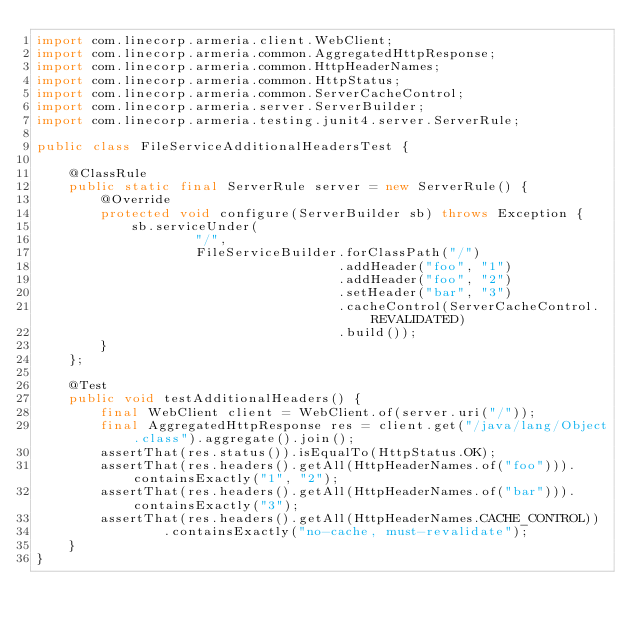<code> <loc_0><loc_0><loc_500><loc_500><_Java_>import com.linecorp.armeria.client.WebClient;
import com.linecorp.armeria.common.AggregatedHttpResponse;
import com.linecorp.armeria.common.HttpHeaderNames;
import com.linecorp.armeria.common.HttpStatus;
import com.linecorp.armeria.common.ServerCacheControl;
import com.linecorp.armeria.server.ServerBuilder;
import com.linecorp.armeria.testing.junit4.server.ServerRule;

public class FileServiceAdditionalHeadersTest {

    @ClassRule
    public static final ServerRule server = new ServerRule() {
        @Override
        protected void configure(ServerBuilder sb) throws Exception {
            sb.serviceUnder(
                    "/",
                    FileServiceBuilder.forClassPath("/")
                                      .addHeader("foo", "1")
                                      .addHeader("foo", "2")
                                      .setHeader("bar", "3")
                                      .cacheControl(ServerCacheControl.REVALIDATED)
                                      .build());
        }
    };

    @Test
    public void testAdditionalHeaders() {
        final WebClient client = WebClient.of(server.uri("/"));
        final AggregatedHttpResponse res = client.get("/java/lang/Object.class").aggregate().join();
        assertThat(res.status()).isEqualTo(HttpStatus.OK);
        assertThat(res.headers().getAll(HttpHeaderNames.of("foo"))).containsExactly("1", "2");
        assertThat(res.headers().getAll(HttpHeaderNames.of("bar"))).containsExactly("3");
        assertThat(res.headers().getAll(HttpHeaderNames.CACHE_CONTROL))
                .containsExactly("no-cache, must-revalidate");
    }
}
</code> 